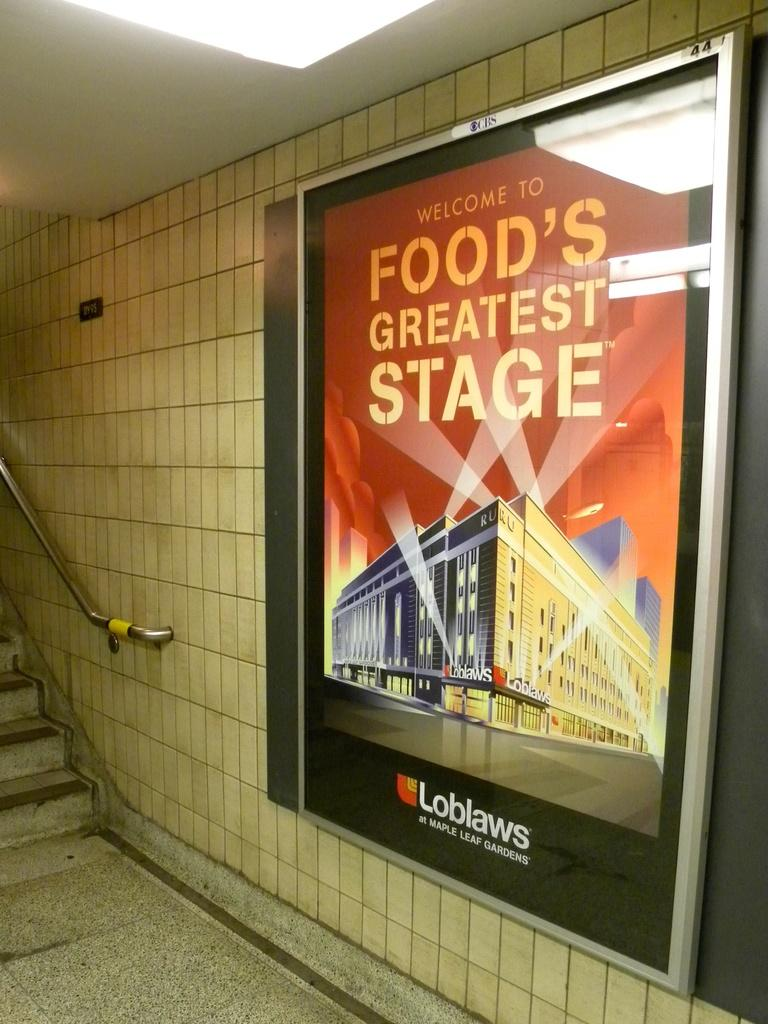<image>
Present a compact description of the photo's key features. A sign by the stairs that says welcome to food's greatest stage. 